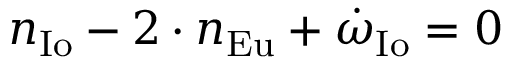<formula> <loc_0><loc_0><loc_500><loc_500>n _ { I o } - 2 \cdot n _ { E u } + { \dot { \omega } } _ { I o } = 0</formula> 